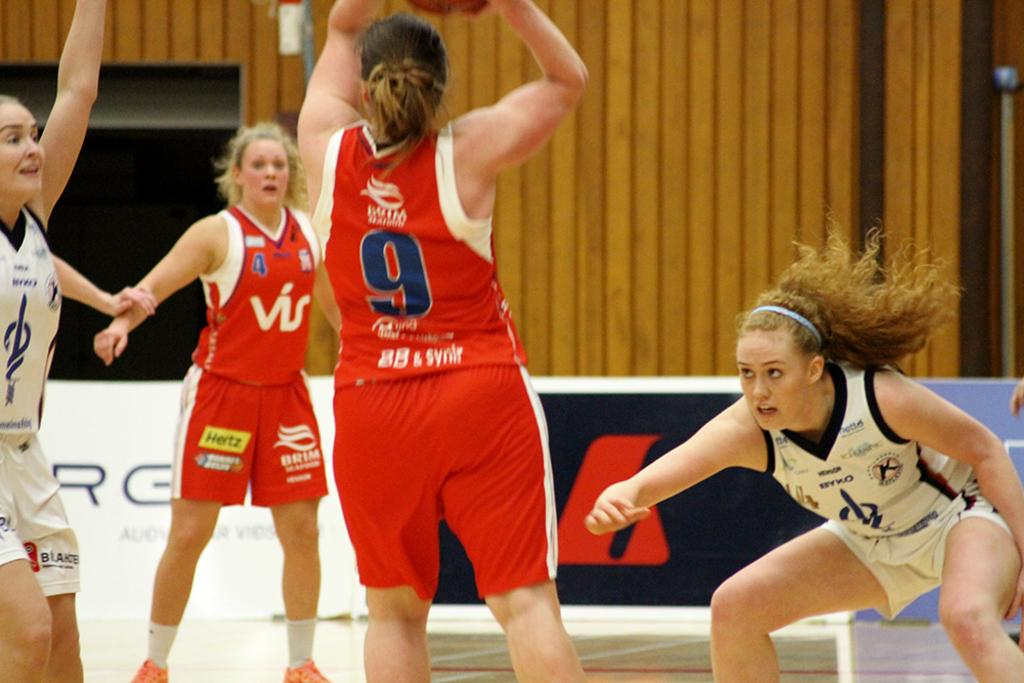<image>
Summarize the visual content of the image. Number 9, wearing a red jersey and shorts attempts to pass a ball to a team mate while an opposing team member watches. 